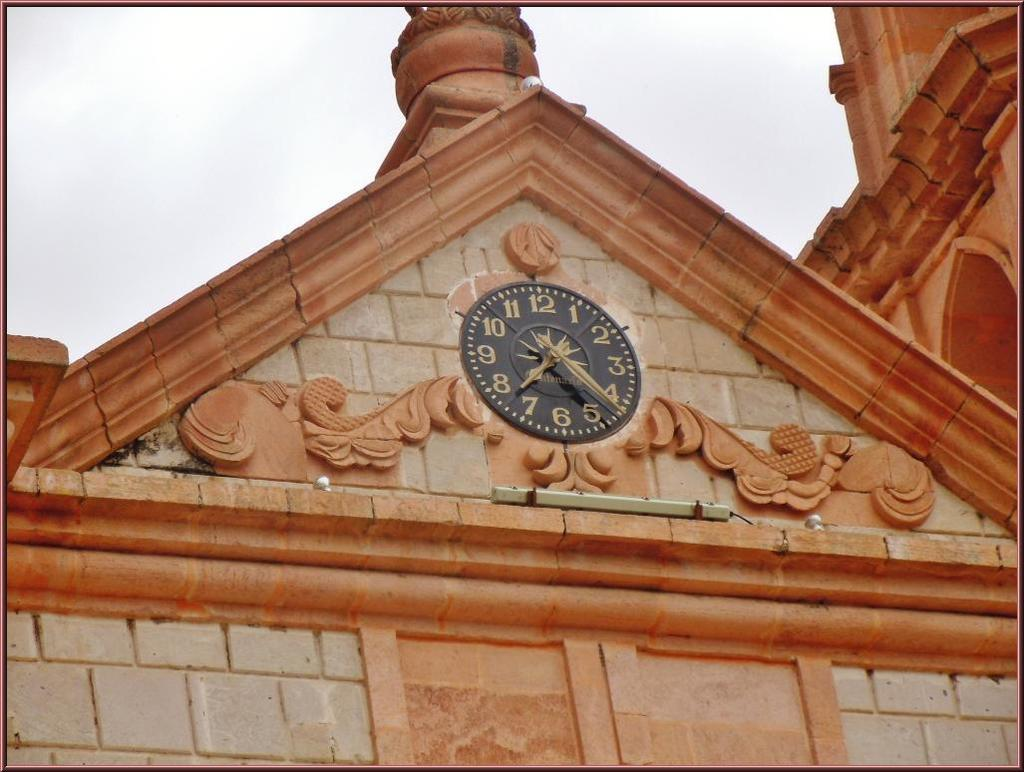<image>
Render a clear and concise summary of the photo. a clock on the outside of a building that says '7:22' on it 